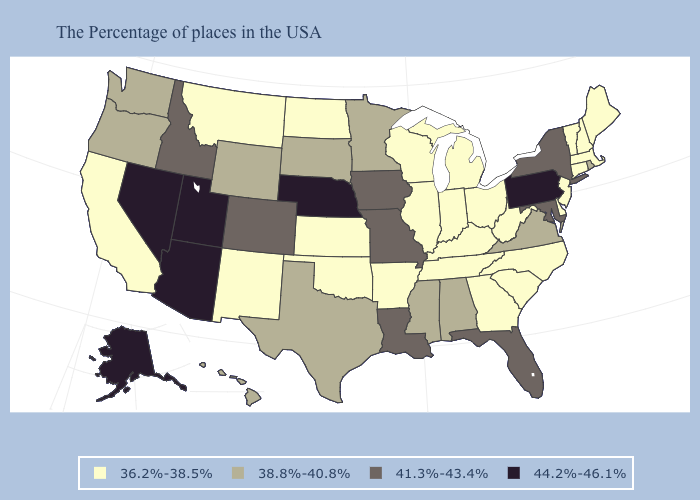Does California have the lowest value in the West?
Concise answer only. Yes. Among the states that border New York , which have the highest value?
Answer briefly. Pennsylvania. What is the lowest value in states that border Rhode Island?
Give a very brief answer. 36.2%-38.5%. What is the highest value in states that border Colorado?
Keep it brief. 44.2%-46.1%. Name the states that have a value in the range 44.2%-46.1%?
Keep it brief. Pennsylvania, Nebraska, Utah, Arizona, Nevada, Alaska. What is the lowest value in the South?
Short answer required. 36.2%-38.5%. What is the lowest value in the MidWest?
Write a very short answer. 36.2%-38.5%. Name the states that have a value in the range 41.3%-43.4%?
Short answer required. New York, Maryland, Florida, Louisiana, Missouri, Iowa, Colorado, Idaho. Name the states that have a value in the range 36.2%-38.5%?
Short answer required. Maine, Massachusetts, New Hampshire, Vermont, Connecticut, New Jersey, Delaware, North Carolina, South Carolina, West Virginia, Ohio, Georgia, Michigan, Kentucky, Indiana, Tennessee, Wisconsin, Illinois, Arkansas, Kansas, Oklahoma, North Dakota, New Mexico, Montana, California. Name the states that have a value in the range 44.2%-46.1%?
Give a very brief answer. Pennsylvania, Nebraska, Utah, Arizona, Nevada, Alaska. Which states have the lowest value in the USA?
Keep it brief. Maine, Massachusetts, New Hampshire, Vermont, Connecticut, New Jersey, Delaware, North Carolina, South Carolina, West Virginia, Ohio, Georgia, Michigan, Kentucky, Indiana, Tennessee, Wisconsin, Illinois, Arkansas, Kansas, Oklahoma, North Dakota, New Mexico, Montana, California. Which states have the highest value in the USA?
Concise answer only. Pennsylvania, Nebraska, Utah, Arizona, Nevada, Alaska. Does West Virginia have a lower value than Michigan?
Quick response, please. No. Name the states that have a value in the range 36.2%-38.5%?
Give a very brief answer. Maine, Massachusetts, New Hampshire, Vermont, Connecticut, New Jersey, Delaware, North Carolina, South Carolina, West Virginia, Ohio, Georgia, Michigan, Kentucky, Indiana, Tennessee, Wisconsin, Illinois, Arkansas, Kansas, Oklahoma, North Dakota, New Mexico, Montana, California. Does Missouri have the highest value in the USA?
Answer briefly. No. 